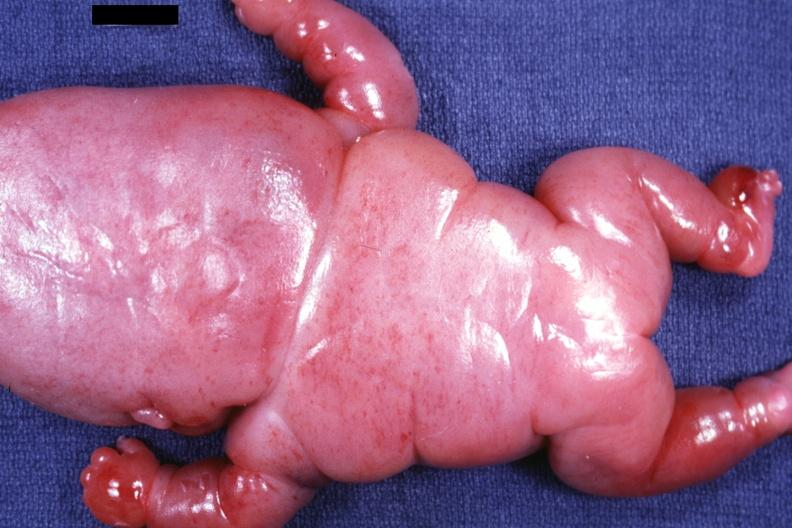does this image show posterior view of body lesions mostly in head neck and thorax?
Answer the question using a single word or phrase. Yes 